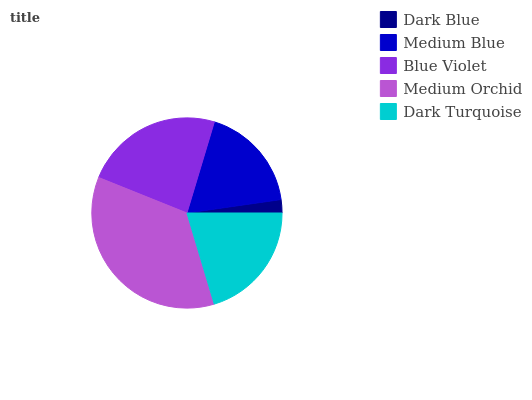Is Dark Blue the minimum?
Answer yes or no. Yes. Is Medium Orchid the maximum?
Answer yes or no. Yes. Is Medium Blue the minimum?
Answer yes or no. No. Is Medium Blue the maximum?
Answer yes or no. No. Is Medium Blue greater than Dark Blue?
Answer yes or no. Yes. Is Dark Blue less than Medium Blue?
Answer yes or no. Yes. Is Dark Blue greater than Medium Blue?
Answer yes or no. No. Is Medium Blue less than Dark Blue?
Answer yes or no. No. Is Dark Turquoise the high median?
Answer yes or no. Yes. Is Dark Turquoise the low median?
Answer yes or no. Yes. Is Blue Violet the high median?
Answer yes or no. No. Is Blue Violet the low median?
Answer yes or no. No. 